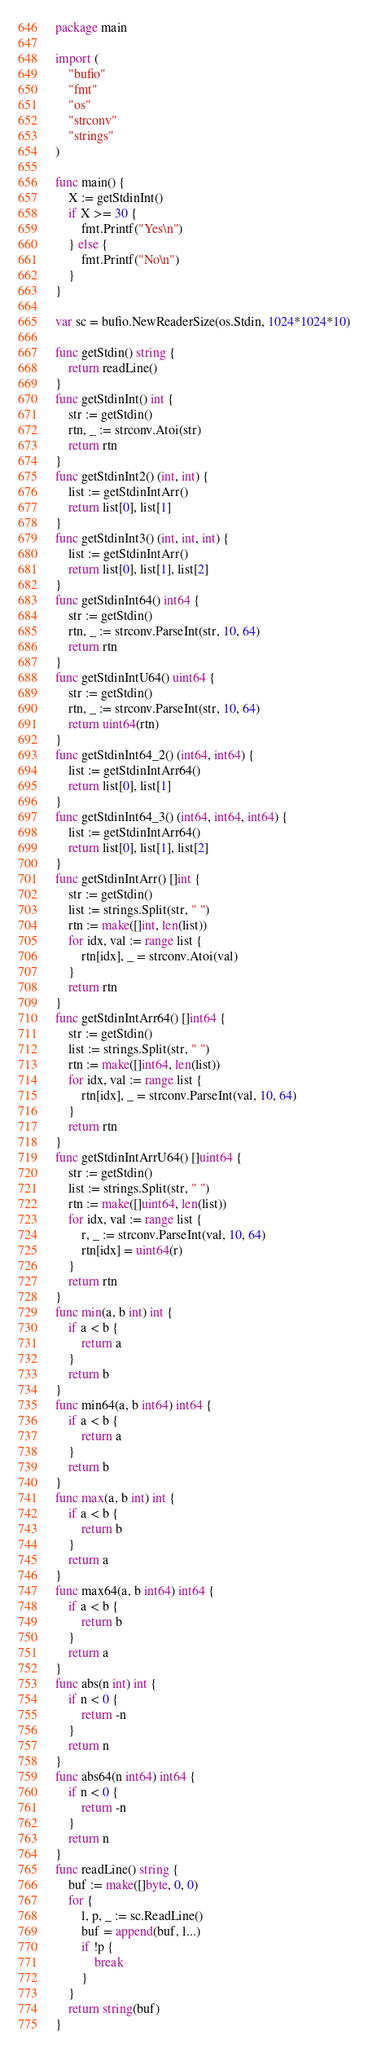<code> <loc_0><loc_0><loc_500><loc_500><_Go_>package main

import (
	"bufio"
	"fmt"
	"os"
	"strconv"
	"strings"
)

func main() {
	X := getStdinInt()
	if X >= 30 {
		fmt.Printf("Yes\n")
	} else {
		fmt.Printf("No\n")
	}
}

var sc = bufio.NewReaderSize(os.Stdin, 1024*1024*10)

func getStdin() string {
	return readLine()
}
func getStdinInt() int {
	str := getStdin()
	rtn, _ := strconv.Atoi(str)
	return rtn
}
func getStdinInt2() (int, int) {
	list := getStdinIntArr()
	return list[0], list[1]
}
func getStdinInt3() (int, int, int) {
	list := getStdinIntArr()
	return list[0], list[1], list[2]
}
func getStdinInt64() int64 {
	str := getStdin()
	rtn, _ := strconv.ParseInt(str, 10, 64)
	return rtn
}
func getStdinIntU64() uint64 {
	str := getStdin()
	rtn, _ := strconv.ParseInt(str, 10, 64)
	return uint64(rtn)
}
func getStdinInt64_2() (int64, int64) {
	list := getStdinIntArr64()
	return list[0], list[1]
}
func getStdinInt64_3() (int64, int64, int64) {
	list := getStdinIntArr64()
	return list[0], list[1], list[2]
}
func getStdinIntArr() []int {
	str := getStdin()
	list := strings.Split(str, " ")
	rtn := make([]int, len(list))
	for idx, val := range list {
		rtn[idx], _ = strconv.Atoi(val)
	}
	return rtn
}
func getStdinIntArr64() []int64 {
	str := getStdin()
	list := strings.Split(str, " ")
	rtn := make([]int64, len(list))
	for idx, val := range list {
		rtn[idx], _ = strconv.ParseInt(val, 10, 64)
	}
	return rtn
}
func getStdinIntArrU64() []uint64 {
	str := getStdin()
	list := strings.Split(str, " ")
	rtn := make([]uint64, len(list))
	for idx, val := range list {
		r, _ := strconv.ParseInt(val, 10, 64)
		rtn[idx] = uint64(r)
	}
	return rtn
}
func min(a, b int) int {
	if a < b {
		return a
	}
	return b
}
func min64(a, b int64) int64 {
	if a < b {
		return a
	}
	return b
}
func max(a, b int) int {
	if a < b {
		return b
	}
	return a
}
func max64(a, b int64) int64 {
	if a < b {
		return b
	}
	return a
}
func abs(n int) int {
	if n < 0 {
		return -n
	}
	return n
}
func abs64(n int64) int64 {
	if n < 0 {
		return -n
	}
	return n
}
func readLine() string {
	buf := make([]byte, 0, 0)
	for {
		l, p, _ := sc.ReadLine()
		buf = append(buf, l...)
		if !p {
			break
		}
	}
	return string(buf)
}
</code> 